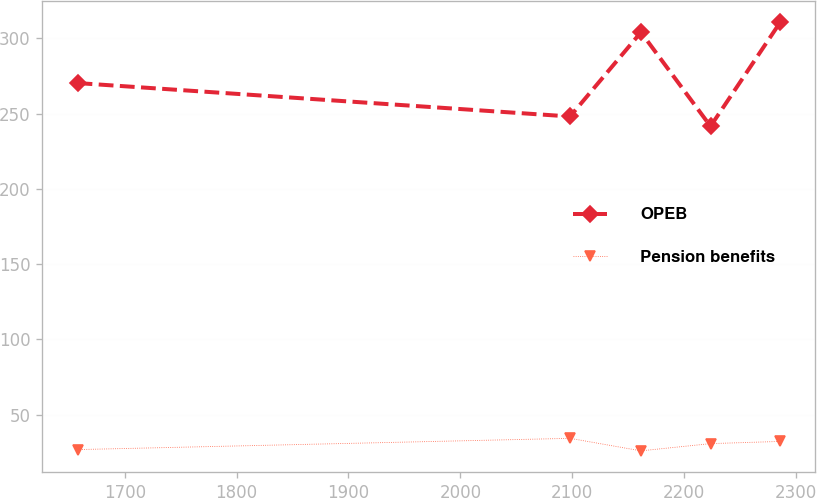Convert chart to OTSL. <chart><loc_0><loc_0><loc_500><loc_500><line_chart><ecel><fcel>OPEB<fcel>Pension benefits<nl><fcel>1657.73<fcel>270.28<fcel>26.84<nl><fcel>2098.11<fcel>248.08<fcel>34.32<nl><fcel>2161.51<fcel>304.01<fcel>26.01<nl><fcel>2223.71<fcel>241.58<fcel>30.8<nl><fcel>2285.91<fcel>310.51<fcel>32.27<nl></chart> 